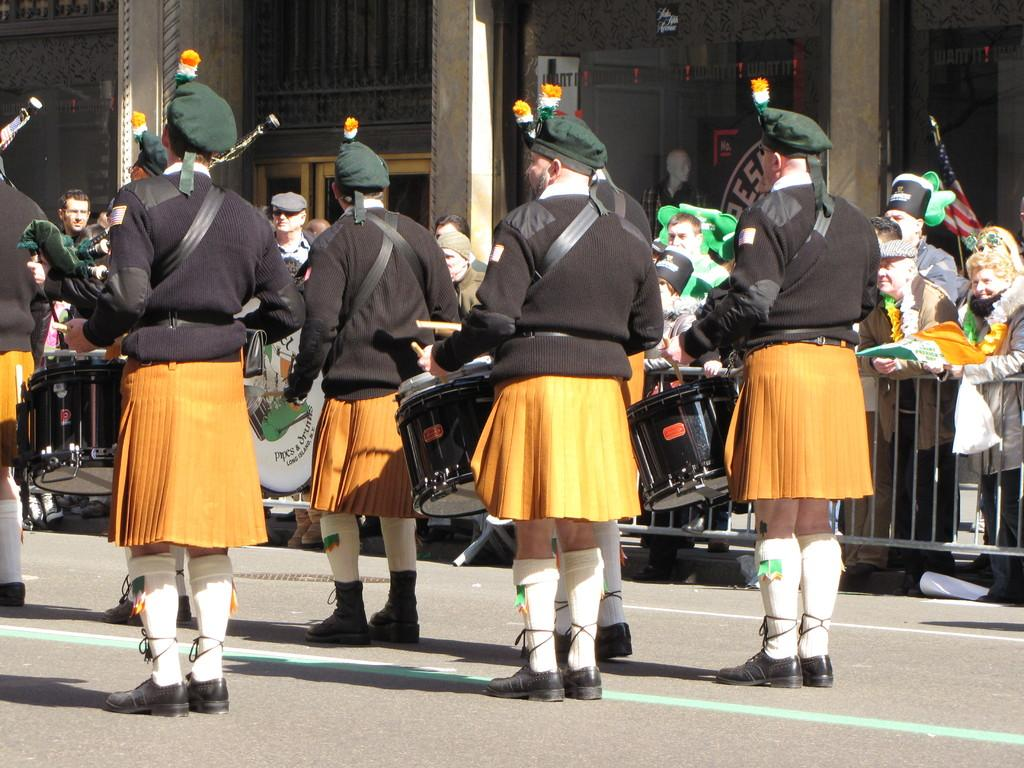How many people are in the group that is visible in the image? There is a group of people in the image, but the exact number is not specified. What are some people in the group wearing? Some people in the group are wearing caps. What are some people in the group doing? Some people in the group are playing drums. What can be seen in the background of the image? There are metal rods, a building, and a flag in the background of the image. What type of plastic item can be seen in the image? There is no plastic item present in the image. What kind of stamp is visible on the flag in the background? There is no stamp visible on the flag in the background; only the flag itself is present. 